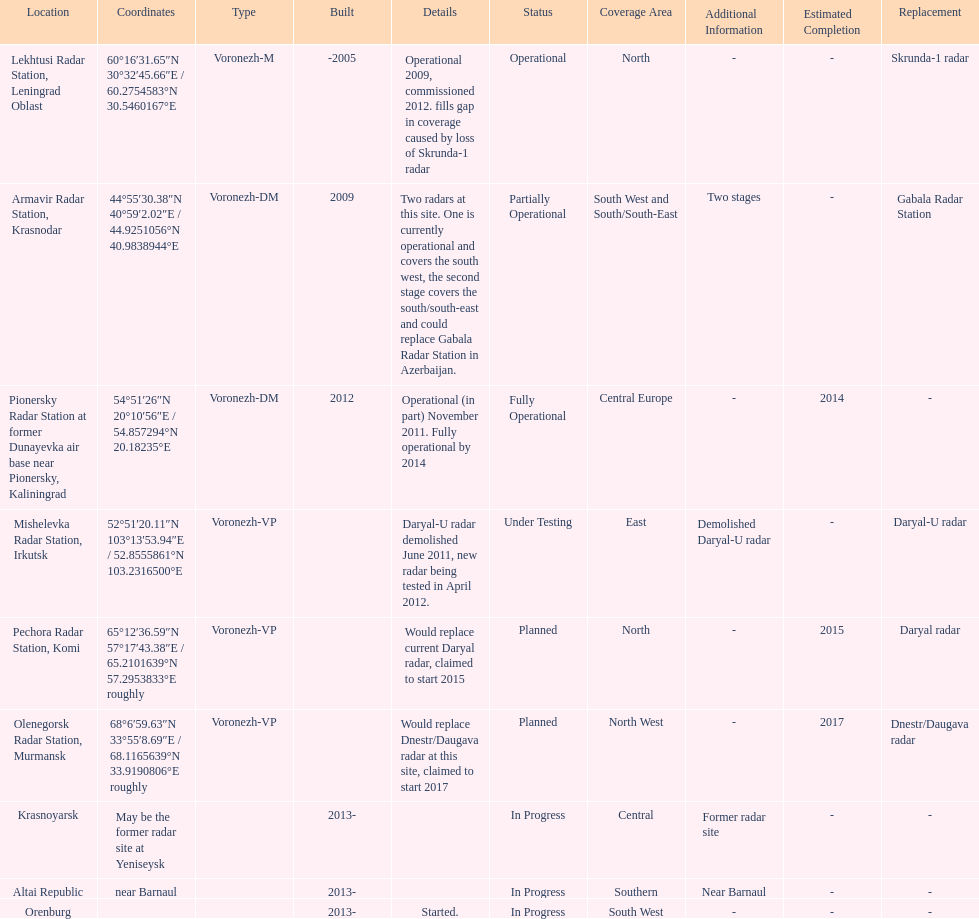What is the total number of locations? 9. 